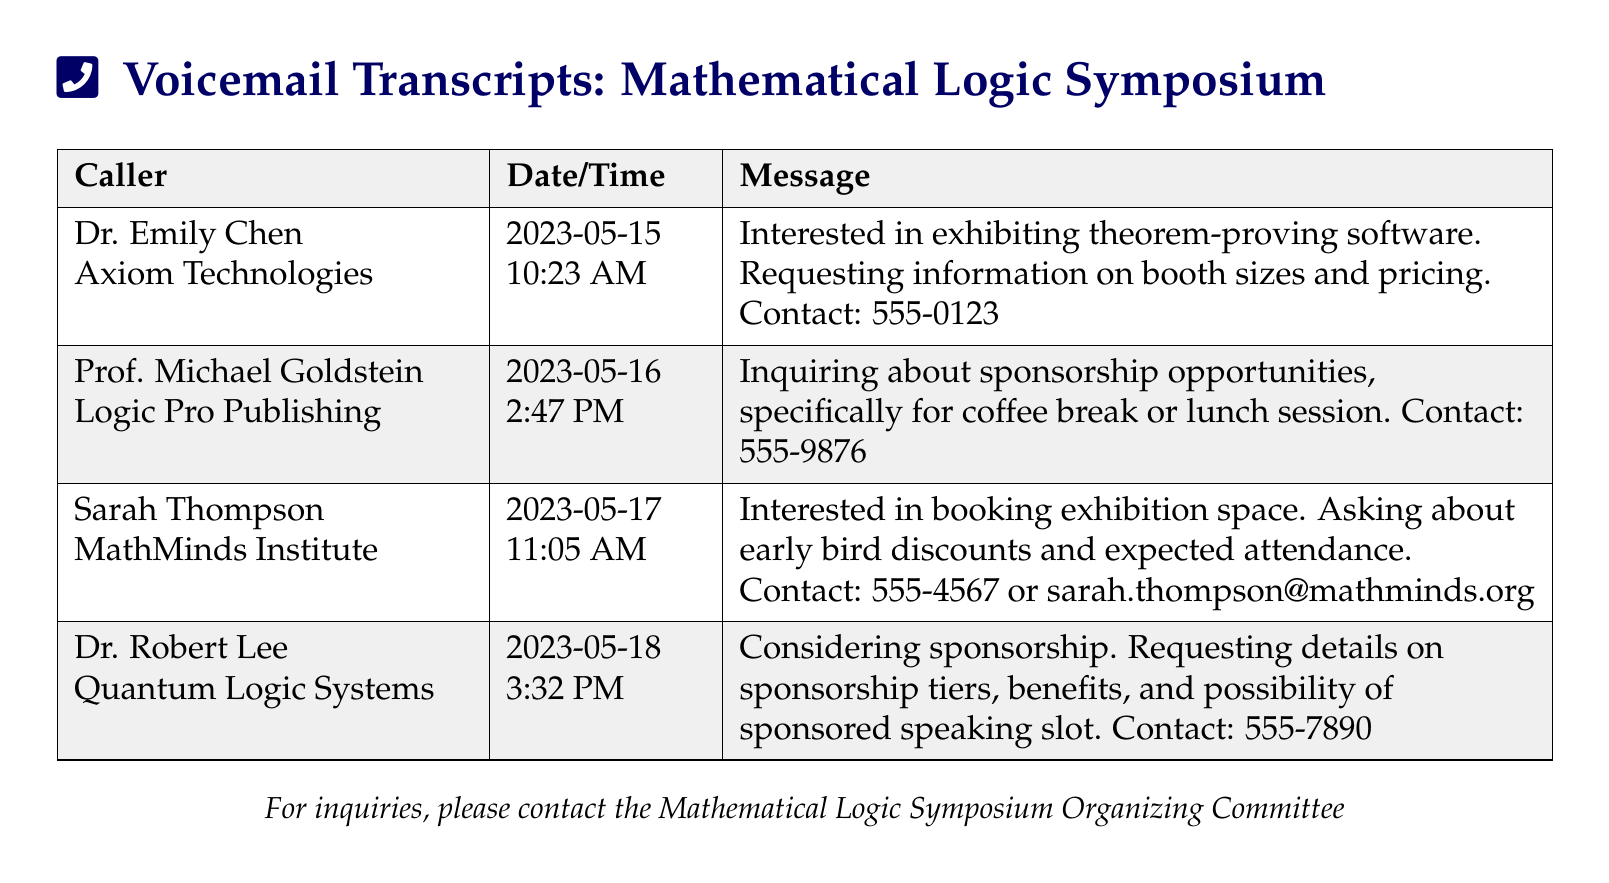What is the name of the first caller? The first caller listed in the document is Dr. Emily Chen.
Answer: Dr. Emily Chen What company is associated with Prof. Michael Goldstein? Prof. Michael Goldstein is representing Logic Pro Publishing.
Answer: Logic Pro Publishing On what date did Sarah Thompson leave a message? Sarah Thompson's message was recorded on May 17, 2023.
Answer: 2023-05-17 What is the contact number provided by Dr. Robert Lee? Dr. Robert Lee provided the contact number 555-7890.
Answer: 555-7890 How many callers inquired about exhibition space? Two callers, Dr. Emily Chen and Sarah Thompson, inquired about exhibition space.
Answer: Two What sponsorship opportunity is Prof. Michael Goldstein interested in? Prof. Michael Goldstein is interested in sponsorship for a coffee break or lunch session.
Answer: Coffee break or lunch session What was the time of the voicemail from Quantum Logic Systems? Dr. Robert Lee's voicemail was recorded at 3:32 PM.
Answer: 3:32 PM What type of software is Dr. Emily Chen interested in exhibiting? Dr. Emily Chen is interested in exhibiting theorem-proving software.
Answer: Theorem-proving software What is the email address provided by Sarah Thompson? The email address provided by Sarah Thompson is sarah.thompson@mathminds.org.
Answer: sarah.thompson@mathminds.org 